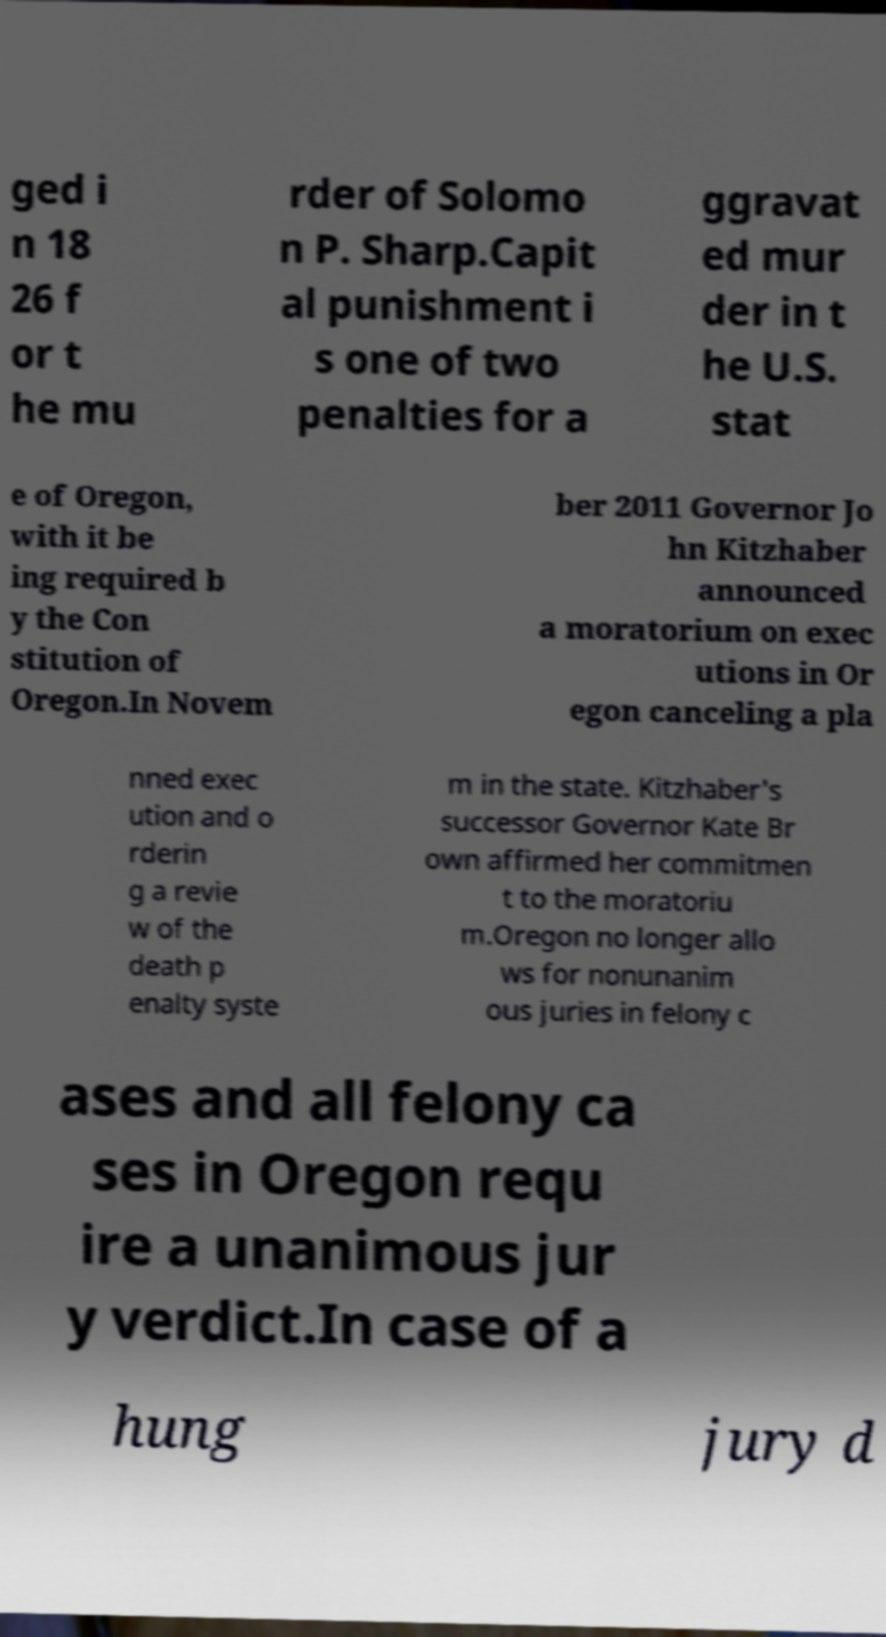Can you accurately transcribe the text from the provided image for me? ged i n 18 26 f or t he mu rder of Solomo n P. Sharp.Capit al punishment i s one of two penalties for a ggravat ed mur der in t he U.S. stat e of Oregon, with it be ing required b y the Con stitution of Oregon.In Novem ber 2011 Governor Jo hn Kitzhaber announced a moratorium on exec utions in Or egon canceling a pla nned exec ution and o rderin g a revie w of the death p enalty syste m in the state. Kitzhaber's successor Governor Kate Br own affirmed her commitmen t to the moratoriu m.Oregon no longer allo ws for nonunanim ous juries in felony c ases and all felony ca ses in Oregon requ ire a unanimous jur y verdict.In case of a hung jury d 